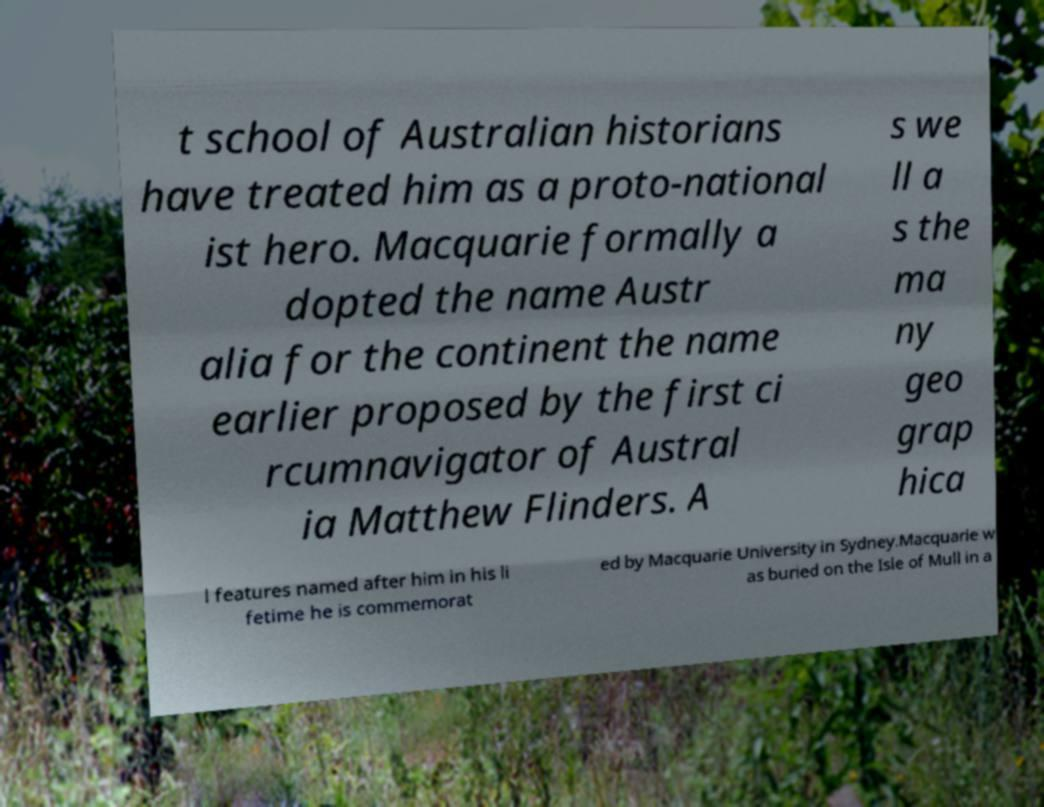For documentation purposes, I need the text within this image transcribed. Could you provide that? t school of Australian historians have treated him as a proto-national ist hero. Macquarie formally a dopted the name Austr alia for the continent the name earlier proposed by the first ci rcumnavigator of Austral ia Matthew Flinders. A s we ll a s the ma ny geo grap hica l features named after him in his li fetime he is commemorat ed by Macquarie University in Sydney.Macquarie w as buried on the Isle of Mull in a 